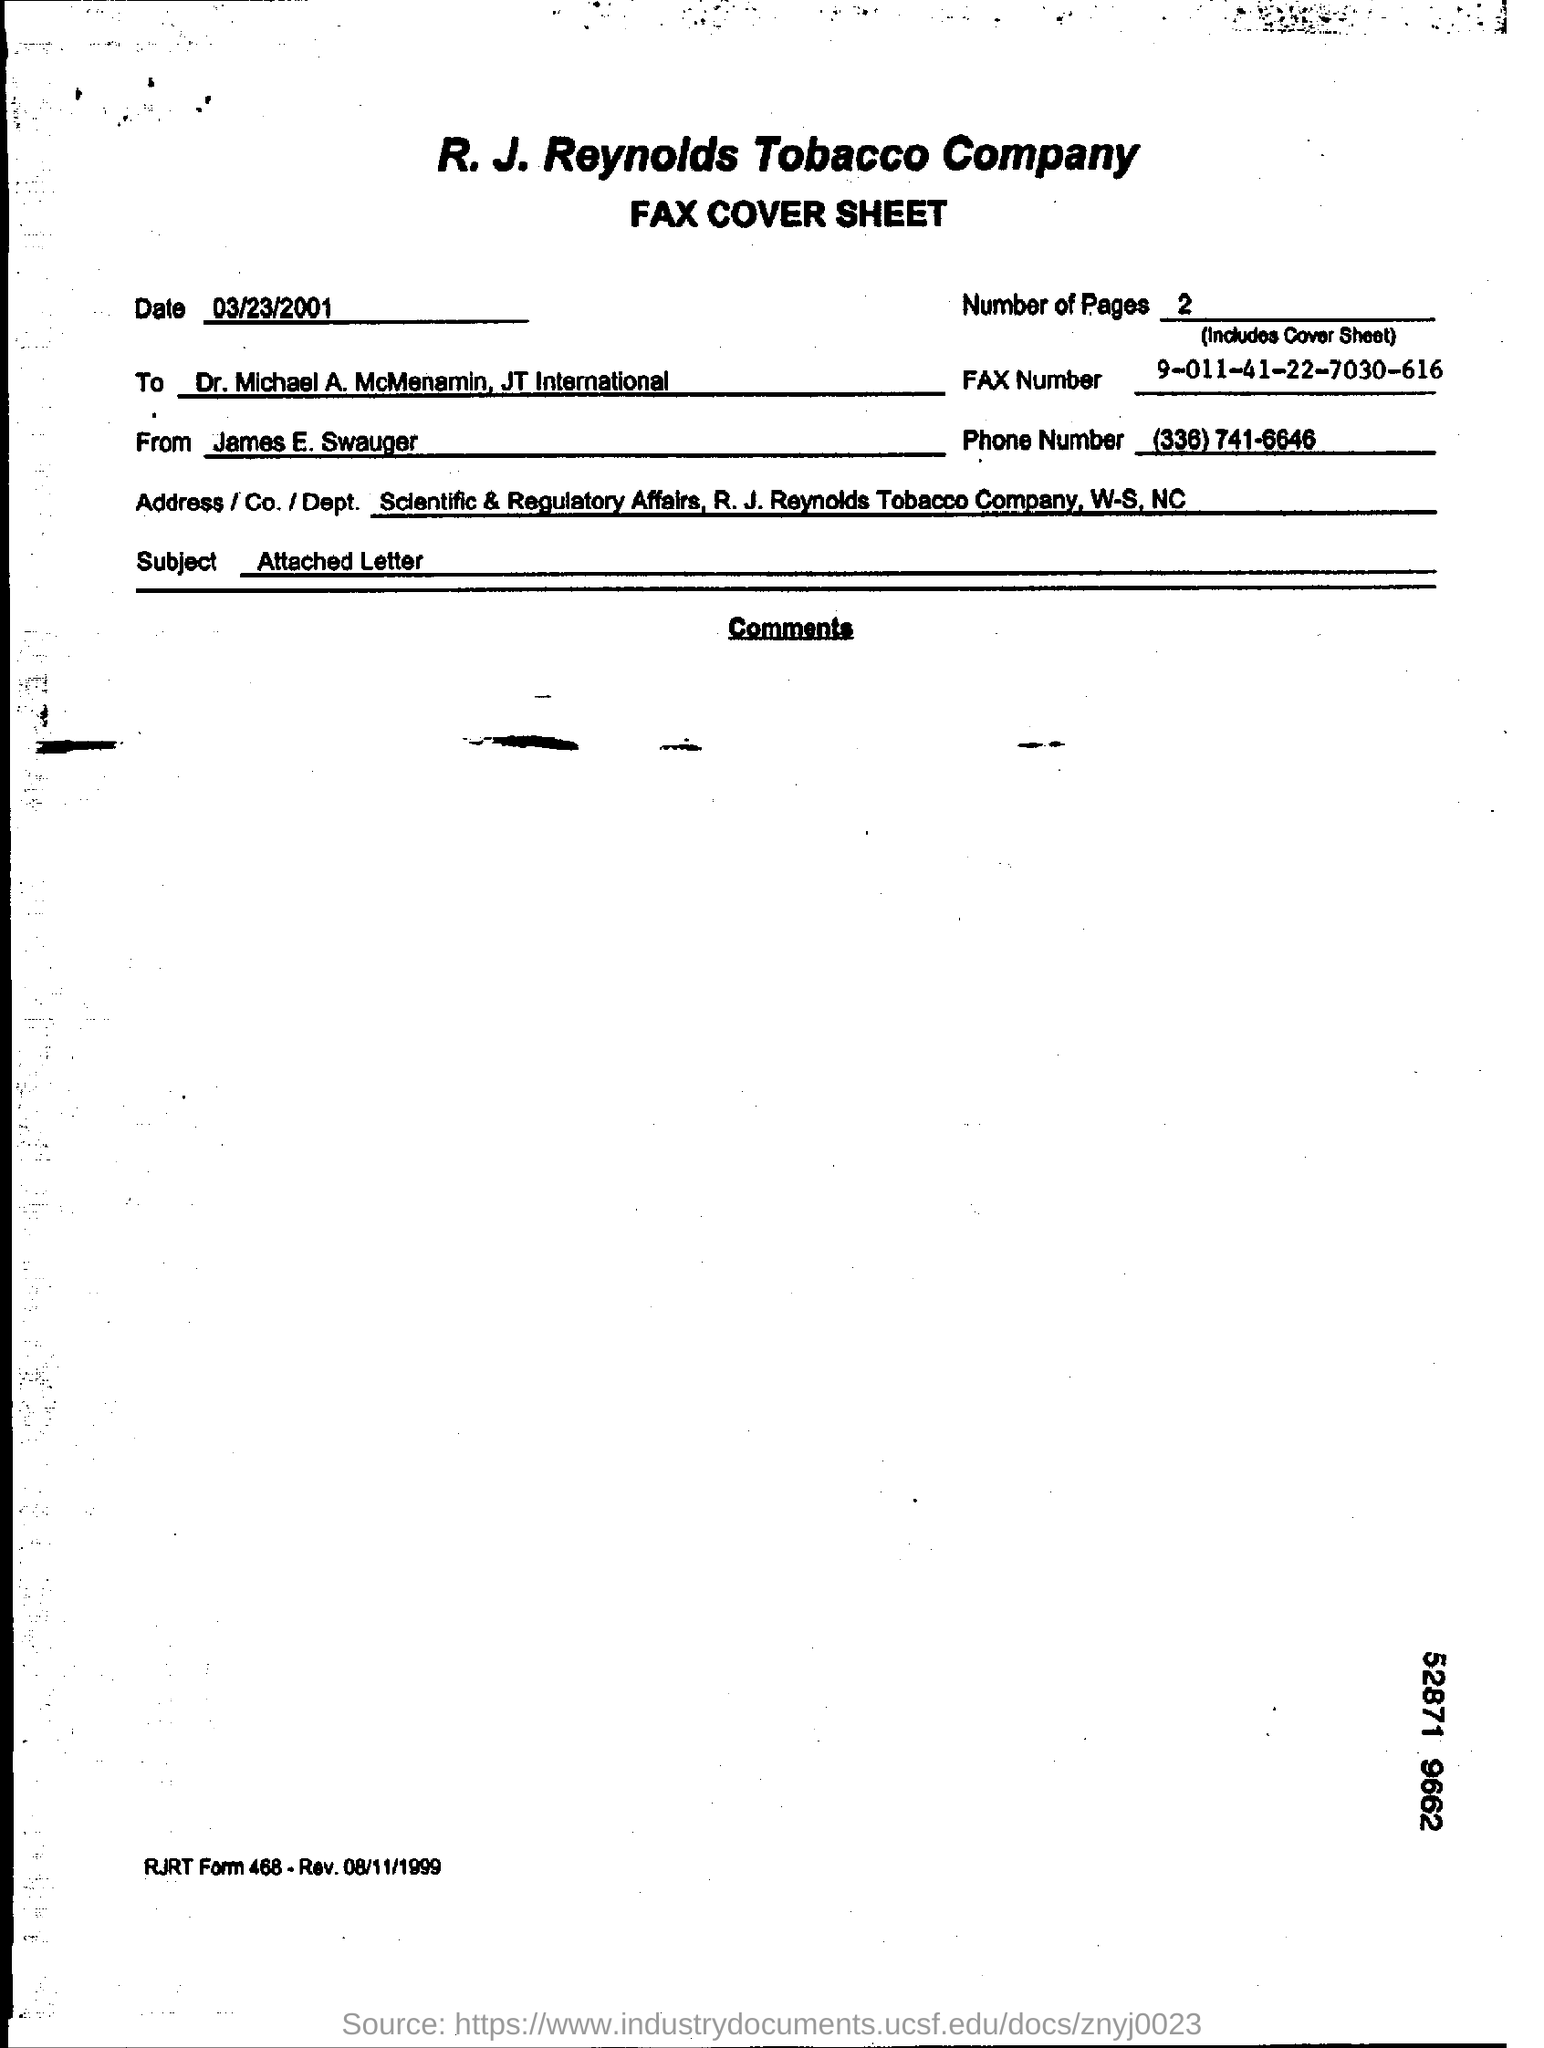Outline some significant characteristics in this image. The sender of the FAX is James E. Swauger. The fax is being sent to Dr. Michael A. McMenamin of JT International. There are two pages in the fax, including the cover sheet. The date mentioned in the fax cover sheet is March 23, 2001. The subject mentioned in the fax cover sheet is the attached letter. 